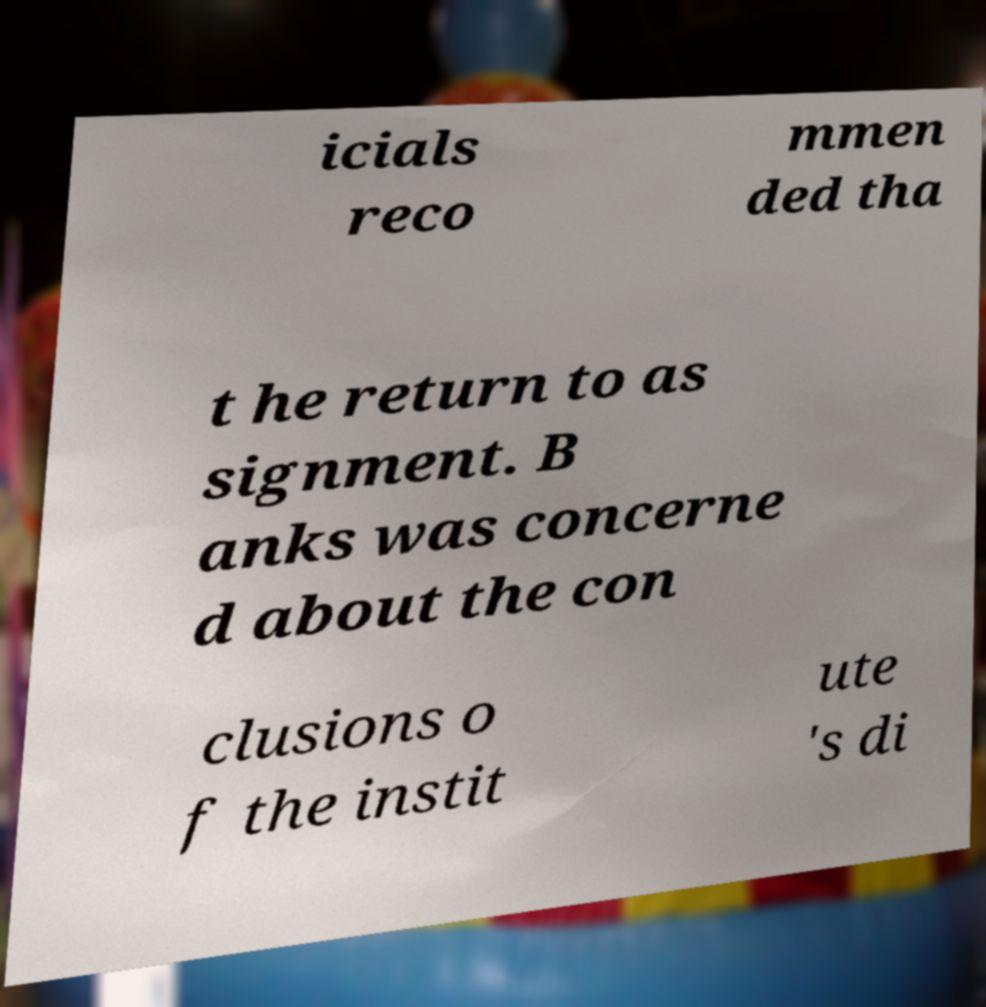Can you read and provide the text displayed in the image?This photo seems to have some interesting text. Can you extract and type it out for me? icials reco mmen ded tha t he return to as signment. B anks was concerne d about the con clusions o f the instit ute 's di 